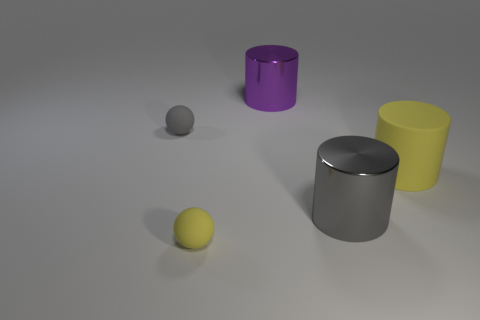The yellow thing that is the same material as the large yellow cylinder is what shape?
Give a very brief answer. Sphere. Is the material of the gray cylinder the same as the tiny yellow sphere?
Offer a terse response. No. Are there fewer rubber balls to the right of the small gray ball than large yellow cylinders that are in front of the gray metal cylinder?
Your response must be concise. No. There is a sphere that is the same color as the big rubber thing; what size is it?
Your answer should be very brief. Small. There is a metallic cylinder behind the small thing that is behind the large yellow thing; what number of gray spheres are behind it?
Your response must be concise. 0. Is there a rubber ball that has the same color as the big matte thing?
Give a very brief answer. Yes. The matte thing that is the same size as the gray matte ball is what color?
Ensure brevity in your answer.  Yellow. Is there a large gray rubber object that has the same shape as the large purple object?
Your response must be concise. No. There is a matte thing that is in front of the gray object on the right side of the purple metallic cylinder; are there any large gray metallic things that are in front of it?
Keep it short and to the point. No. There is another metal thing that is the same size as the purple thing; what is its shape?
Offer a terse response. Cylinder. 